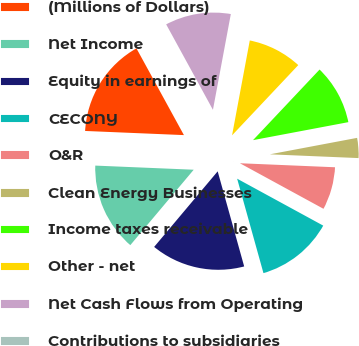Convert chart to OTSL. <chart><loc_0><loc_0><loc_500><loc_500><pie_chart><fcel>(Millions of Dollars)<fcel>Net Income<fcel>Equity in earnings of<fcel>CECONY<fcel>O&R<fcel>Clean Energy Businesses<fcel>Income taxes receivable<fcel>Other - net<fcel>Net Cash Flows from Operating<fcel>Contributions to subsidiaries<nl><fcel>16.36%<fcel>14.54%<fcel>15.45%<fcel>12.73%<fcel>7.27%<fcel>3.64%<fcel>10.0%<fcel>9.09%<fcel>10.91%<fcel>0.0%<nl></chart> 